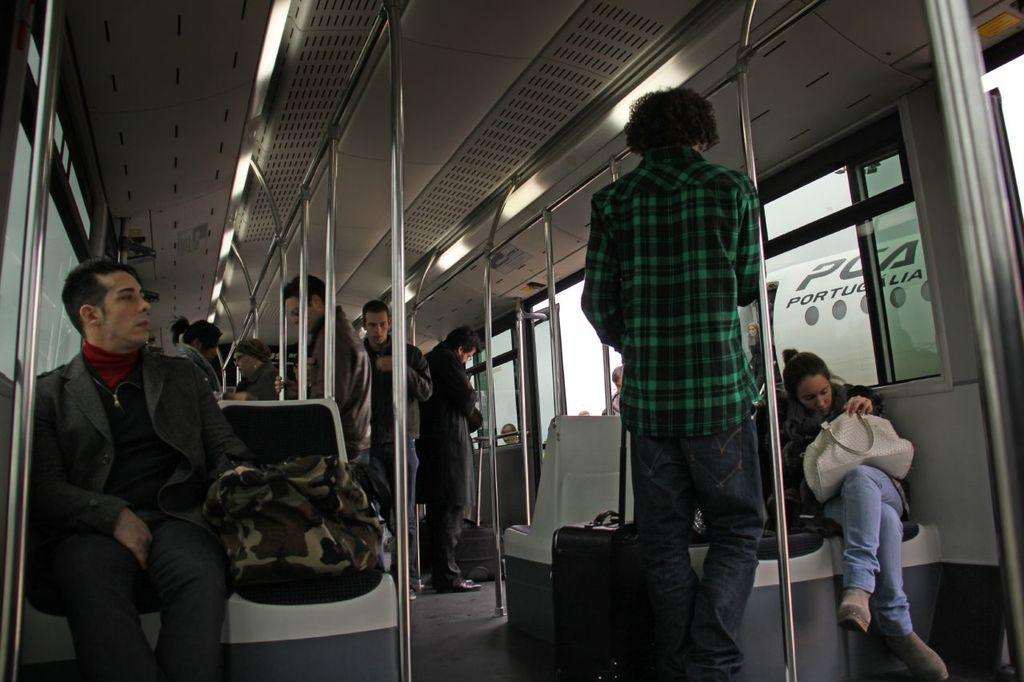What is the setting of the image? The image is of the inside of a train. What are the people in the image doing? There are people sitting on chairs and standing in the train. Can you see any ants crawling on the floor of the train in the image? There are no ants visible in the image. What type of winter clothing are the people wearing in the image? The image does not show any people wearing winter clothing, as it does not depict a winter scene. 